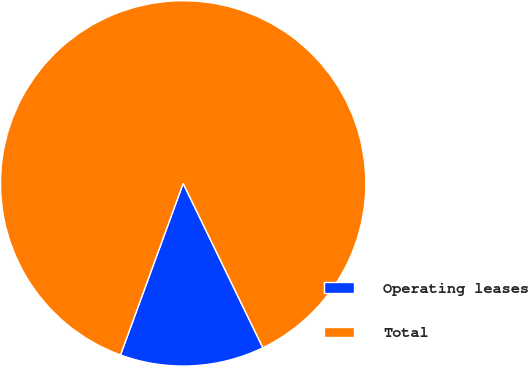Convert chart to OTSL. <chart><loc_0><loc_0><loc_500><loc_500><pie_chart><fcel>Operating leases<fcel>Total<nl><fcel>12.76%<fcel>87.24%<nl></chart> 